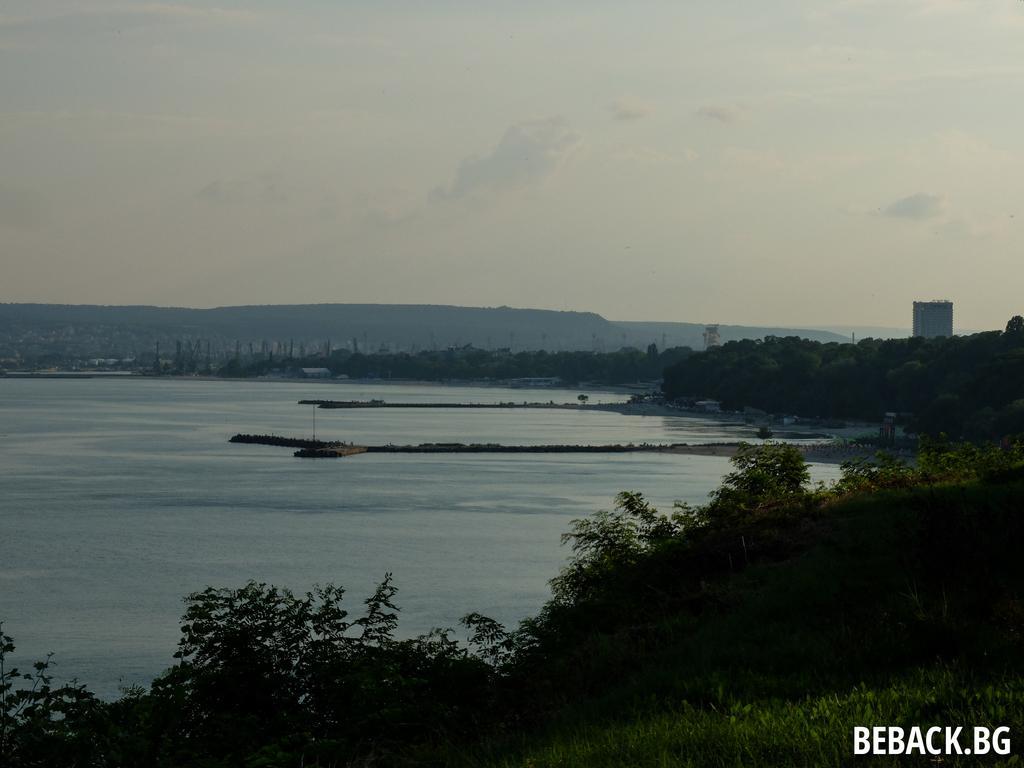Please provide a concise description of this image. In the image there is a sea on the left side with trees all over the place on the right side, in the back it seems to be a hill and above its sky with clouds. 